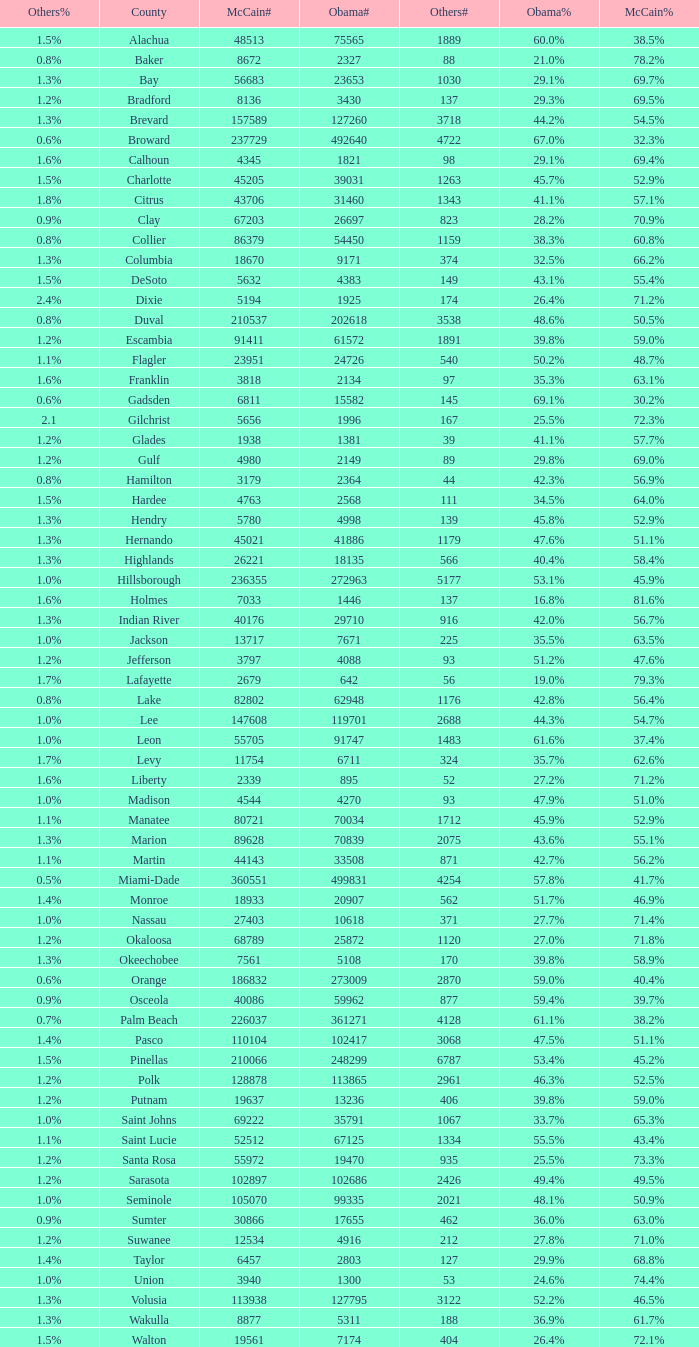What was the number of others votes in Columbia county? 374.0. 